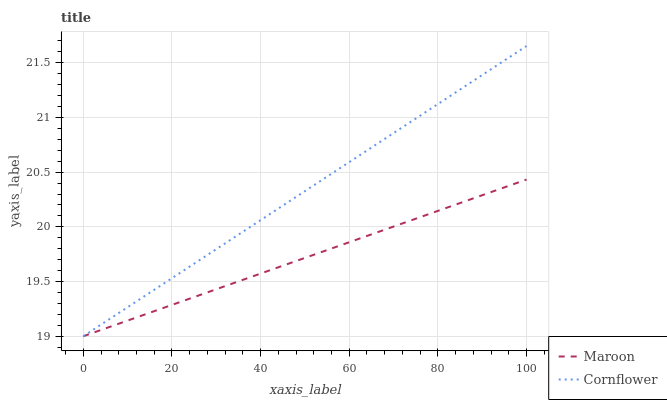Does Maroon have the minimum area under the curve?
Answer yes or no. Yes. Does Cornflower have the maximum area under the curve?
Answer yes or no. Yes. Does Maroon have the maximum area under the curve?
Answer yes or no. No. Is Cornflower the smoothest?
Answer yes or no. Yes. Is Maroon the roughest?
Answer yes or no. Yes. Is Maroon the smoothest?
Answer yes or no. No. Does Cornflower have the highest value?
Answer yes or no. Yes. Does Maroon have the highest value?
Answer yes or no. No. Does Cornflower intersect Maroon?
Answer yes or no. Yes. Is Cornflower less than Maroon?
Answer yes or no. No. Is Cornflower greater than Maroon?
Answer yes or no. No. 